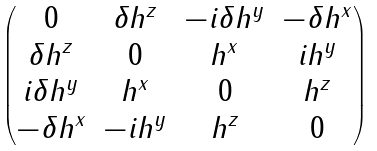<formula> <loc_0><loc_0><loc_500><loc_500>\begin{pmatrix} 0 & \delta h ^ { z } & - i \delta h ^ { y } & - \delta h ^ { x } \\ \delta h ^ { z } & 0 & h ^ { x } & i h ^ { y } \\ i \delta h ^ { y } & h ^ { x } & 0 & h ^ { z } \\ - \delta h ^ { x } & - i h ^ { y } & h ^ { z } & 0 \end{pmatrix}</formula> 